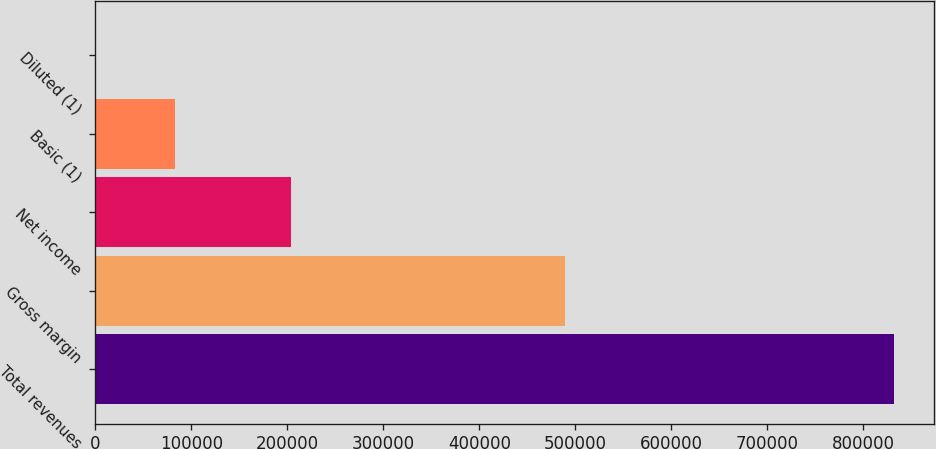Convert chart to OTSL. <chart><loc_0><loc_0><loc_500><loc_500><bar_chart><fcel>Total revenues<fcel>Gross margin<fcel>Net income<fcel>Basic (1)<fcel>Diluted (1)<nl><fcel>831599<fcel>488773<fcel>203581<fcel>83161<fcel>1.21<nl></chart> 